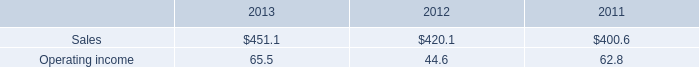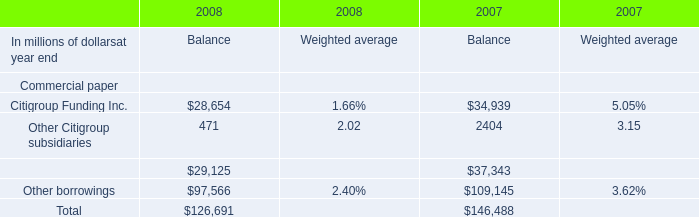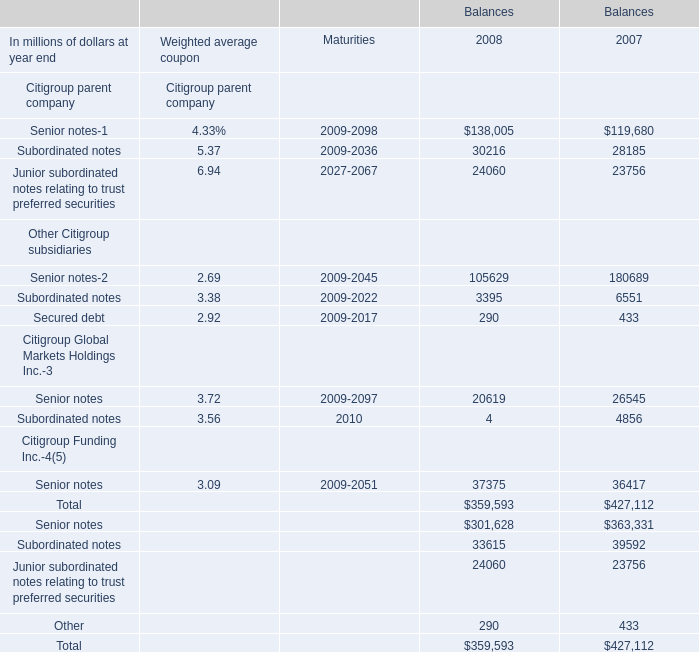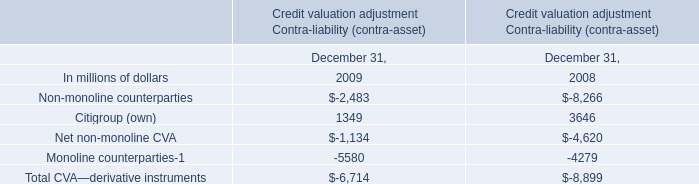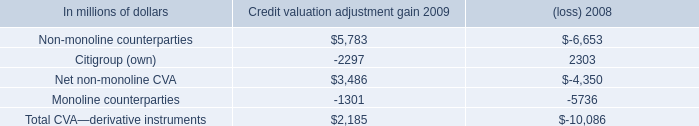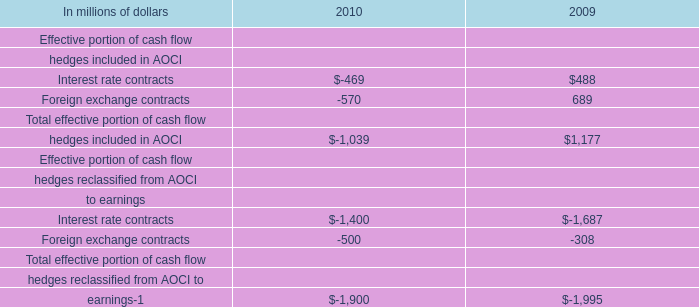What was the total amount of Citigroup parent company greater than 0 in 2008 for Balances? (in million) 
Computations: ((138005 + 30216) + 24060)
Answer: 192281.0. 